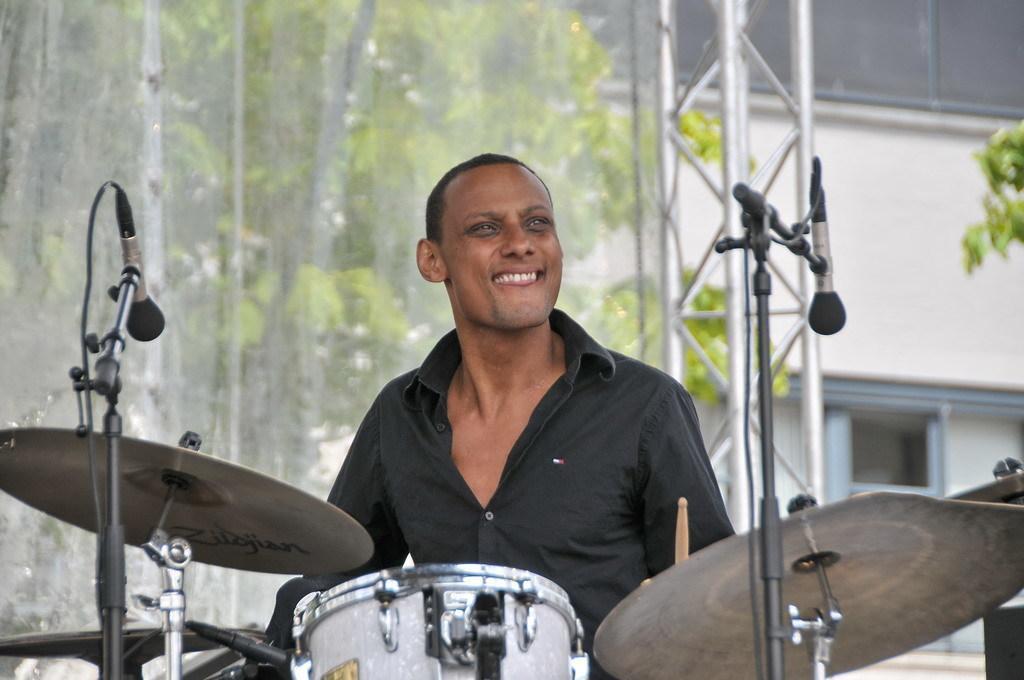Could you give a brief overview of what you see in this image? In this image we can see a man holding sticks. we can also see mics with stands and drums in front of him. On the backside we can see a tree, pole and a building with windows. 